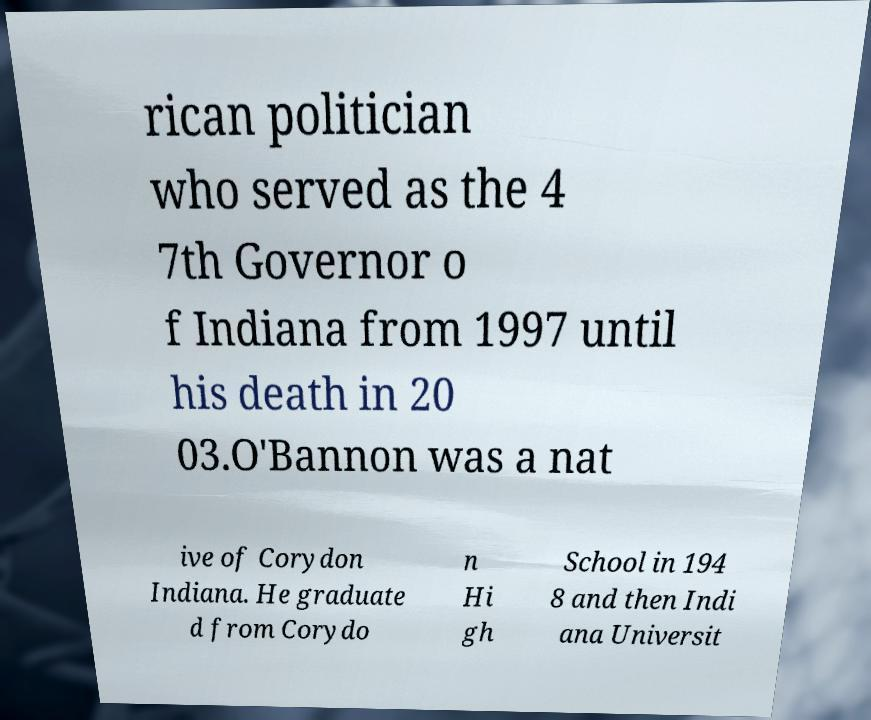I need the written content from this picture converted into text. Can you do that? rican politician who served as the 4 7th Governor o f Indiana from 1997 until his death in 20 03.O'Bannon was a nat ive of Corydon Indiana. He graduate d from Corydo n Hi gh School in 194 8 and then Indi ana Universit 